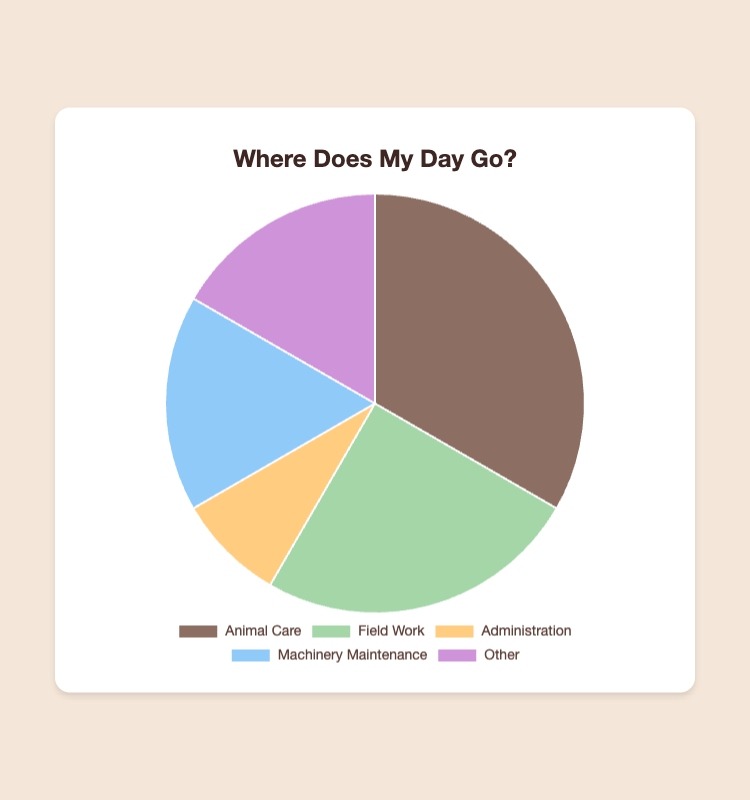Which category has the highest number of hours? By looking at the pie chart, the largest segment represents the category with the highest number of hours.
Answer: Animal Care How many more hours are dedicated to Animal Care than Administration? From the chart, Animal Care is 4 hours and Administration is 1 hour. The difference is 4 - 1.
Answer: 3 hours What percentage of the day is spent on Field Work? There are a total of 12 hours (4 + 3 + 1 + 2 + 2). Field Work is 3 hours. The percentage is (3/12) * 100.
Answer: 25% How do Machinery Maintenance and Other categories contribute to the total time together? Combine the hours for Machinery Maintenance (2) and Other (2), giving a total of 2 + 2.
Answer: 4 hours Is the time spent on Animal Care more than the combined time spent on Field Work and Administration? Sum hours for Field Work (3) and Administration (1), which is 3 + 1 = 4. Compare this to Animal Care's 4 hours.
Answer: No Which color represents the Administration category? From the chart, the segment color identified for Administration is looked up from the visual.
Answer: Orange What's the average time spent on all activities per day? The total time is 12 hours and there are 5 categories. Average time is 12 / 5.
Answer: 2.4 hours What is the smallest segment in the pie chart and how many hours does it represent? The smallest segment will be visually smallest and represent Administration.
Answer: 1 hour If we combine Field Work and Machinery Maintenance, how much time would that represent compared to Animal Care? Field Work (3 hours) + Machinery Maintenance (2 hours) is 5 hours. Compare this with Animal Care's 4 hours.
Answer: 5 hours, more than Animal Care Are the hours spent on Animal Care and Other the same? Visually compare the segments for Animal Care and Other. Animal Care is 4 hours and Other is 2 hours.
Answer: No 